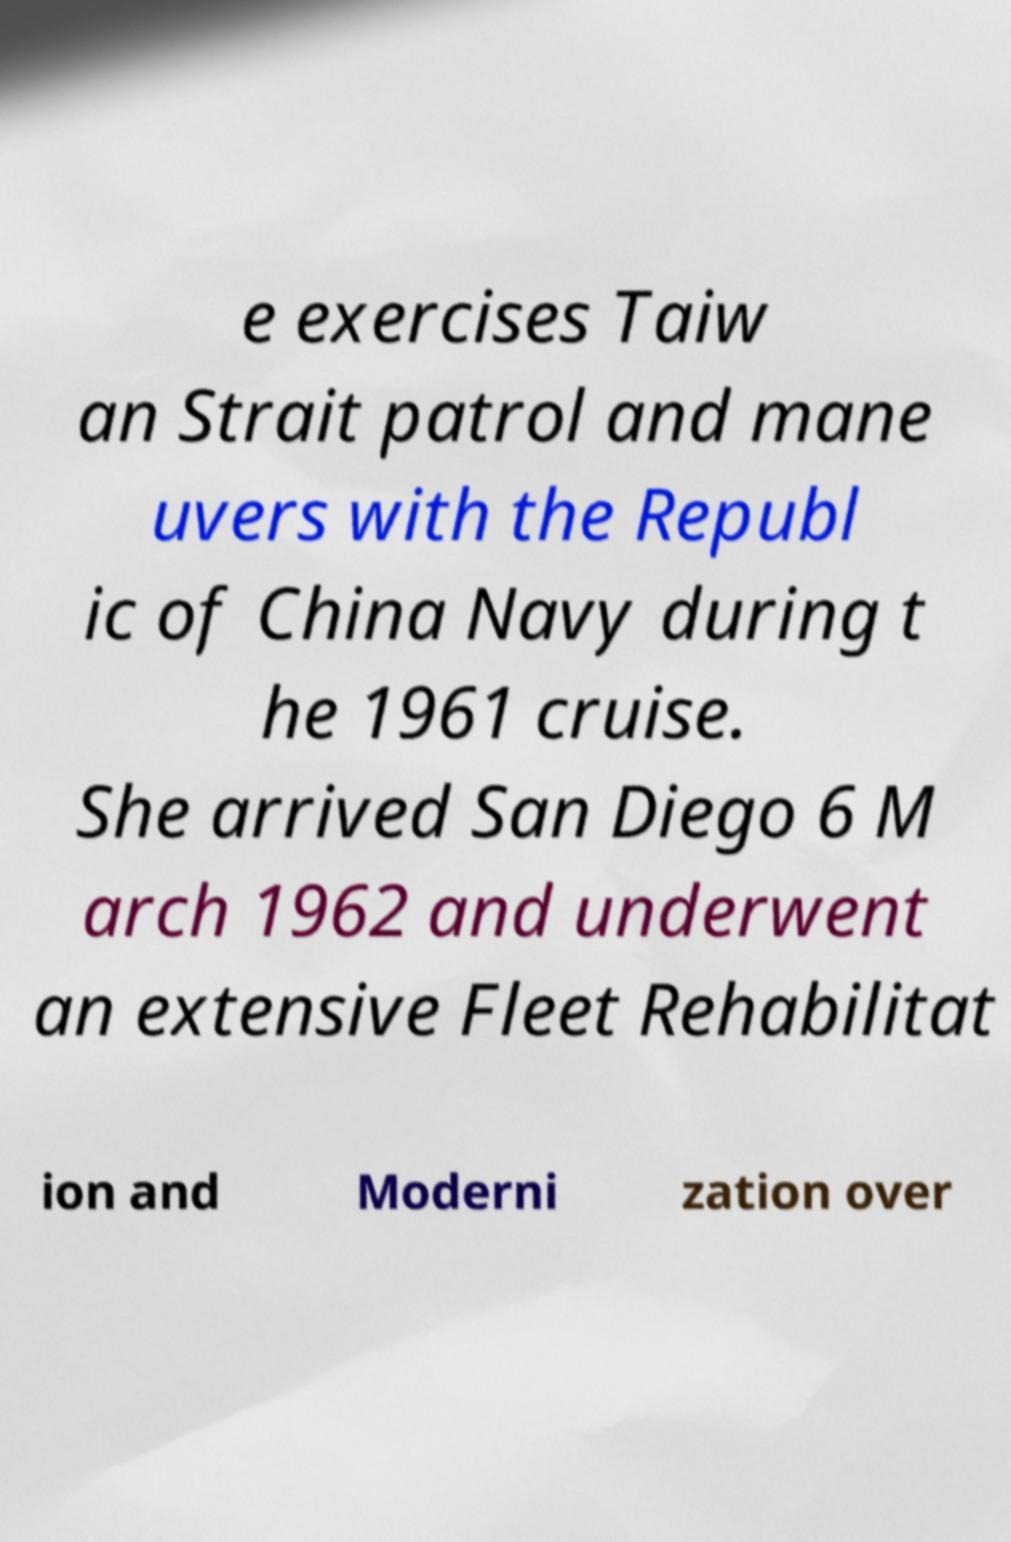Please read and relay the text visible in this image. What does it say? e exercises Taiw an Strait patrol and mane uvers with the Republ ic of China Navy during t he 1961 cruise. She arrived San Diego 6 M arch 1962 and underwent an extensive Fleet Rehabilitat ion and Moderni zation over 